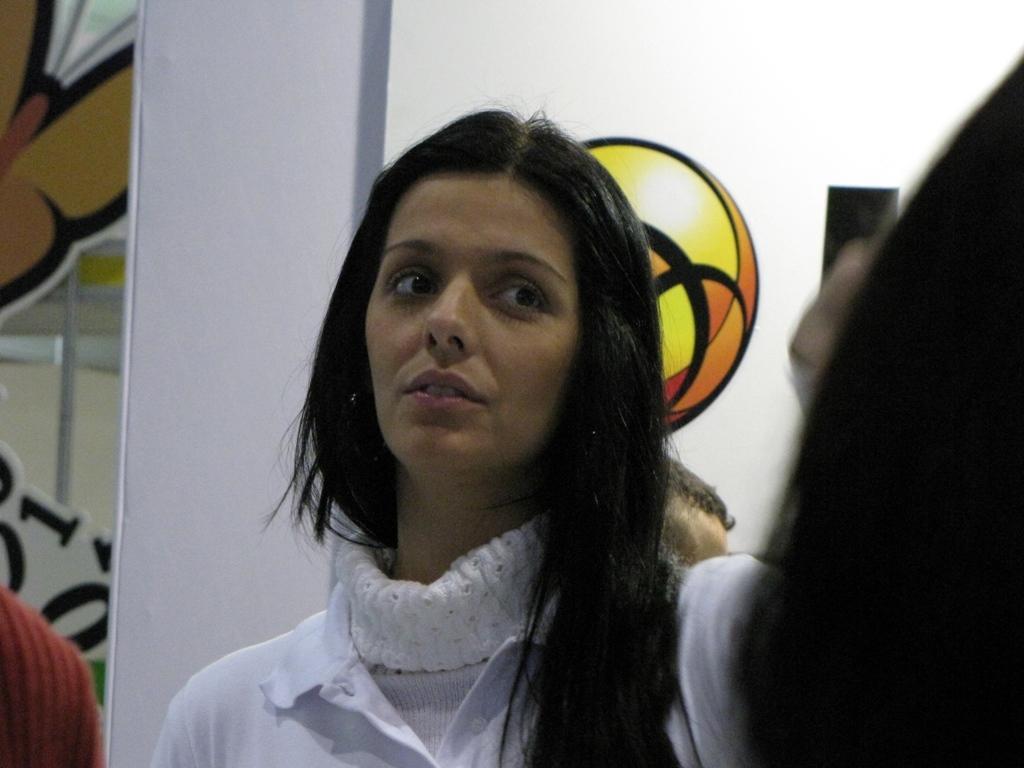Can you describe this image briefly? In the center of the image we can see a woman wearing a white shirt. In the background there is a wall with a sticker on it. 